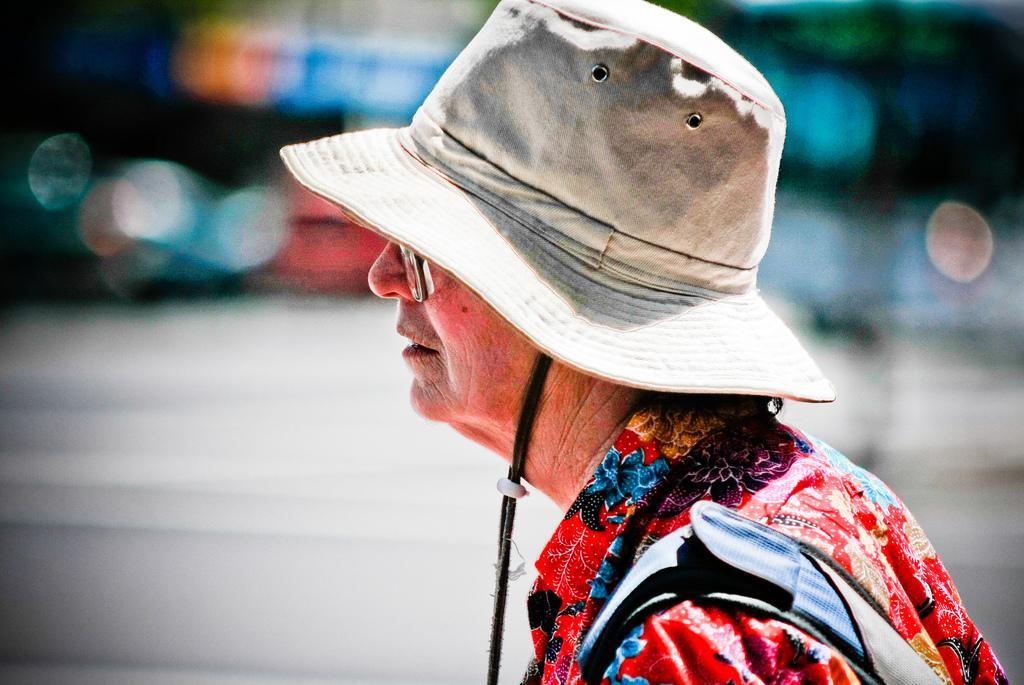How would you summarize this image in a sentence or two? In this image we can see a person wore a hat. There is a blur background. 